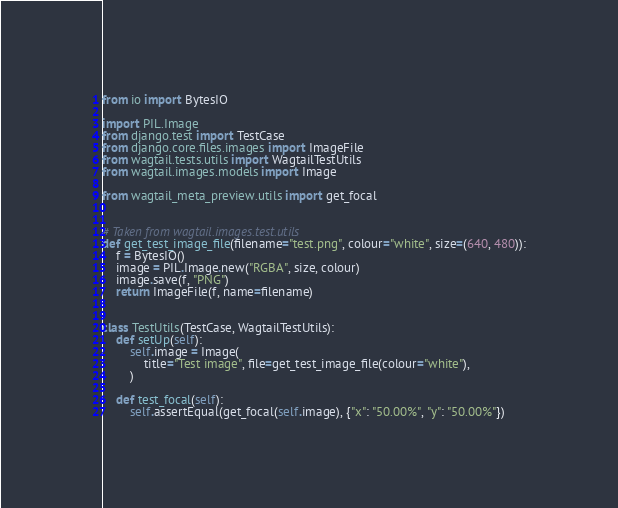<code> <loc_0><loc_0><loc_500><loc_500><_Python_>from io import BytesIO

import PIL.Image
from django.test import TestCase
from django.core.files.images import ImageFile
from wagtail.tests.utils import WagtailTestUtils
from wagtail.images.models import Image

from wagtail_meta_preview.utils import get_focal


# Taken from wagtail.images.test.utils
def get_test_image_file(filename="test.png", colour="white", size=(640, 480)):
    f = BytesIO()
    image = PIL.Image.new("RGBA", size, colour)
    image.save(f, "PNG")
    return ImageFile(f, name=filename)


class TestUtils(TestCase, WagtailTestUtils):
    def setUp(self):
        self.image = Image(
            title="Test image", file=get_test_image_file(colour="white"),
        )

    def test_focal(self):
        self.assertEqual(get_focal(self.image), {"x": "50.00%", "y": "50.00%"})
</code> 